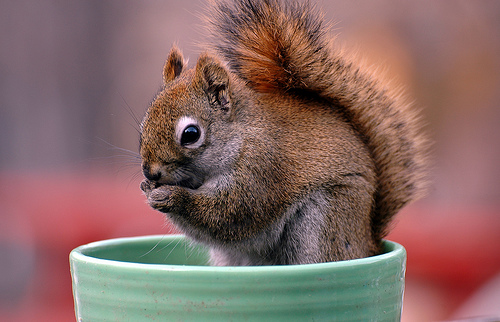<image>
Is there a bowl under the squirrel? Yes. The bowl is positioned underneath the squirrel, with the squirrel above it in the vertical space. Where is the squirrel in relation to the bowl? Is it in the bowl? Yes. The squirrel is contained within or inside the bowl, showing a containment relationship. Is the squirrel in the pot? Yes. The squirrel is contained within or inside the pot, showing a containment relationship. Is there a squirrel in front of the flower pot? No. The squirrel is not in front of the flower pot. The spatial positioning shows a different relationship between these objects. 